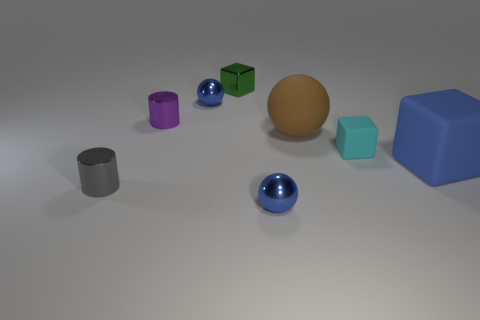Add 1 large cubes. How many objects exist? 9 Subtract all cylinders. How many objects are left? 6 Subtract all red metallic spheres. Subtract all big brown matte spheres. How many objects are left? 7 Add 8 tiny blue metal objects. How many tiny blue metal objects are left? 10 Add 3 large blue spheres. How many large blue spheres exist? 3 Subtract 0 brown cylinders. How many objects are left? 8 